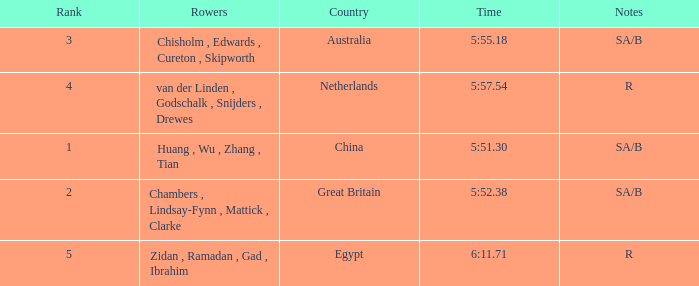What country is ranked larger than 4? Egypt. 